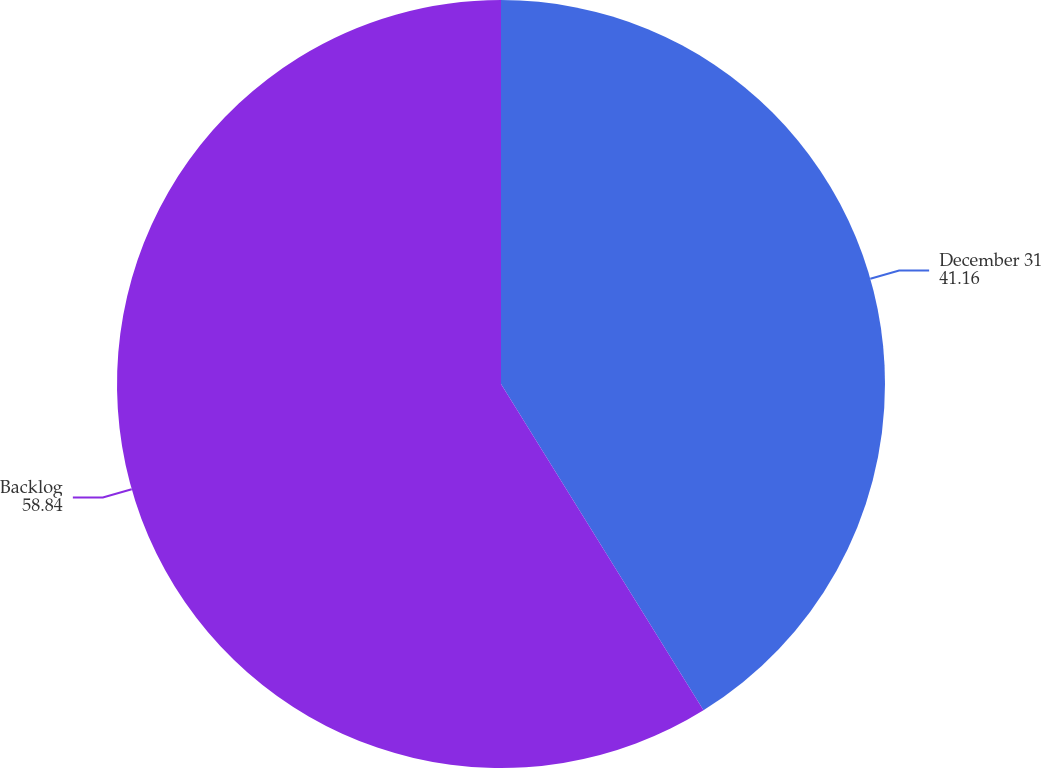<chart> <loc_0><loc_0><loc_500><loc_500><pie_chart><fcel>December 31<fcel>Backlog<nl><fcel>41.16%<fcel>58.84%<nl></chart> 